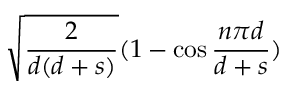<formula> <loc_0><loc_0><loc_500><loc_500>\sqrt { \frac { 2 } { d ( d + s ) } } ( 1 - \cos { \frac { n \pi d } { d + s } } )</formula> 